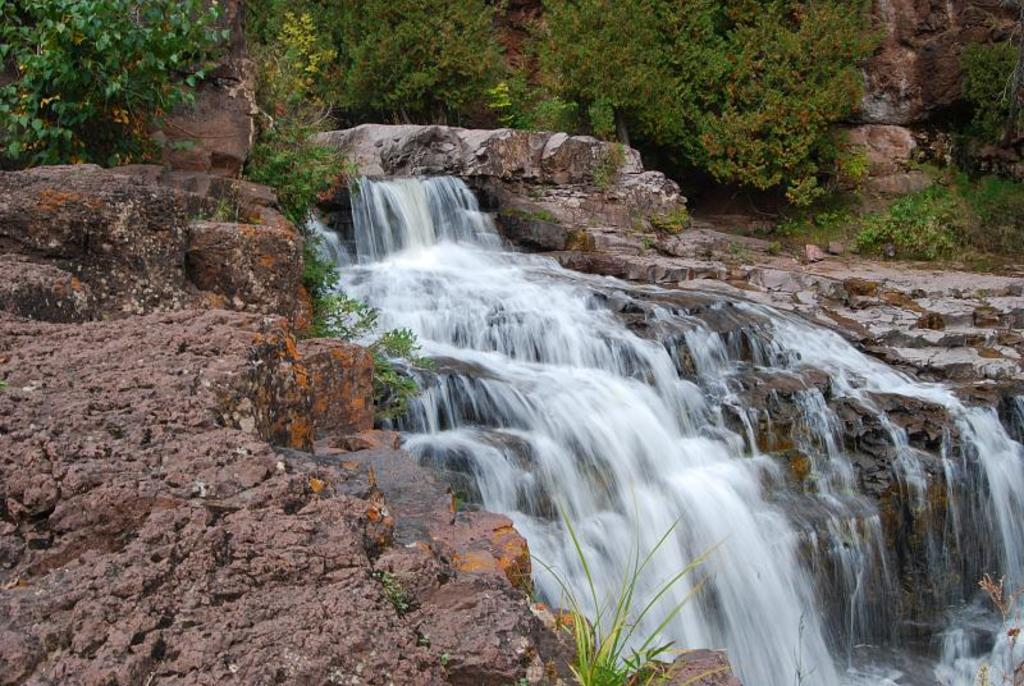What is located in the center of the image? There are trees, stones, plants, grass, and water visible in the center of the image. Can you describe the vegetation in the center of the image? There are trees and plants in the center of the image. What type of terrain is visible in the center of the image? The terrain includes grass and stones. Is there any water visible in the center of the image? Yes, there is water visible in the center of the image. What type of clock is hanging on the tree in the center of the image? There is no clock present in the image; it only features trees, stones, plants, grass, and water in the center. What type of engine is powering the rail in the center of the image? There is no rail or engine present in the image; it only features trees, stones, plants, grass, and water in the center. 